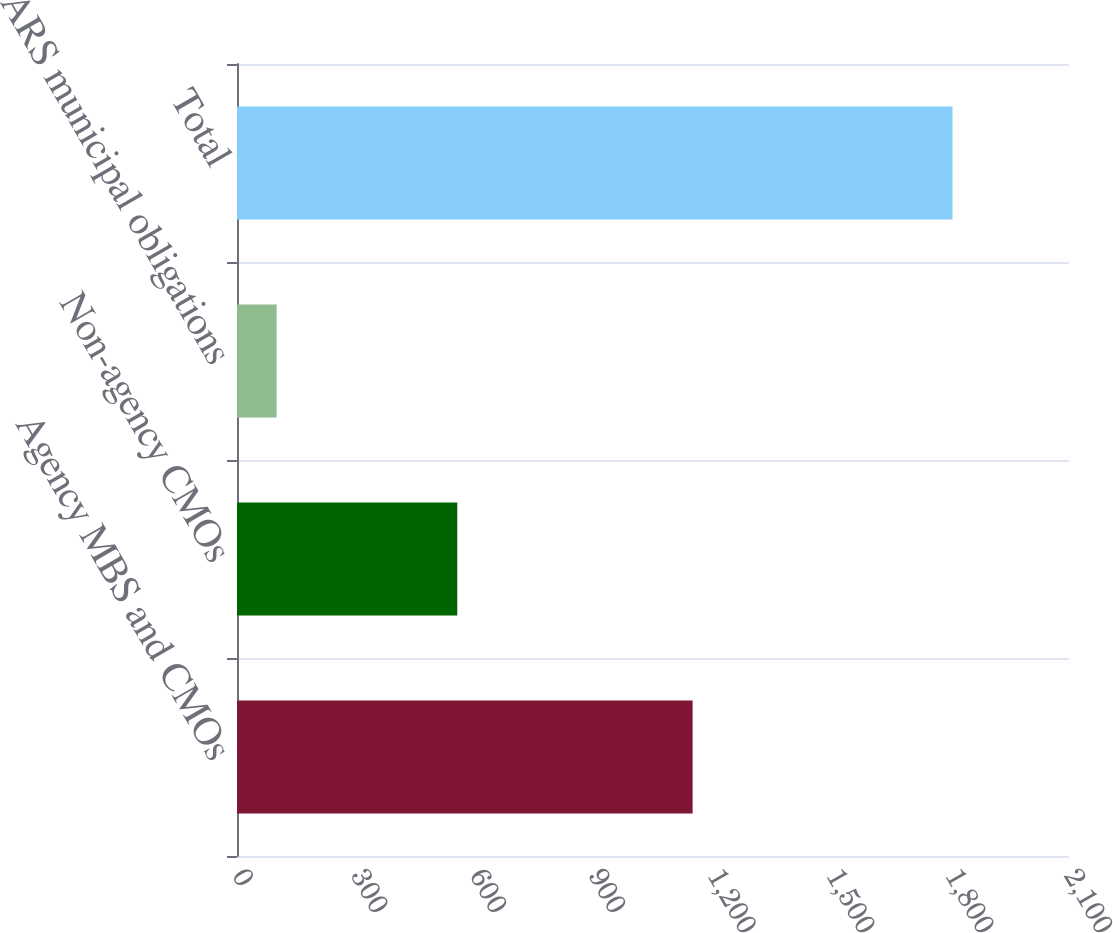<chart> <loc_0><loc_0><loc_500><loc_500><bar_chart><fcel>Agency MBS and CMOs<fcel>Non-agency CMOs<fcel>ARS municipal obligations<fcel>Total<nl><fcel>1150<fcel>556<fcel>100<fcel>1806<nl></chart> 